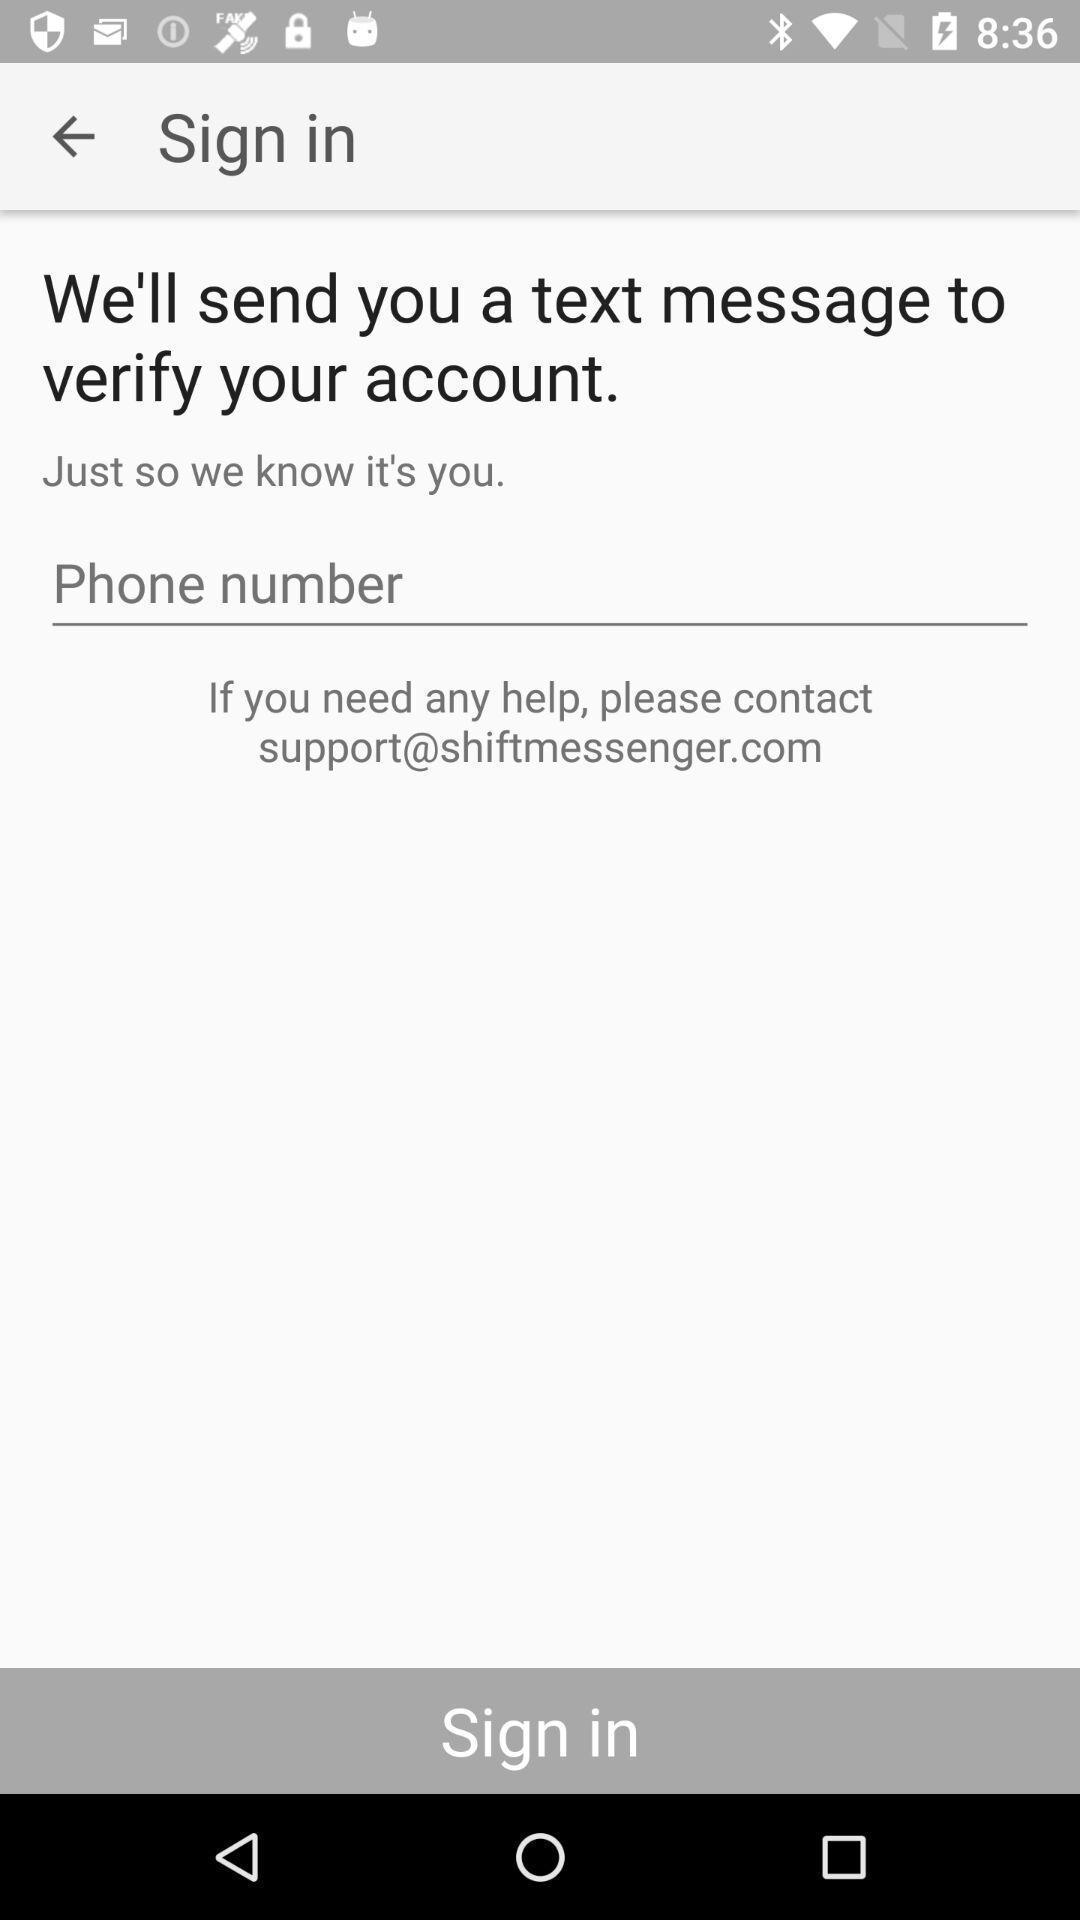Tell me what you see in this picture. Sign in page shows to enter number to create account. 